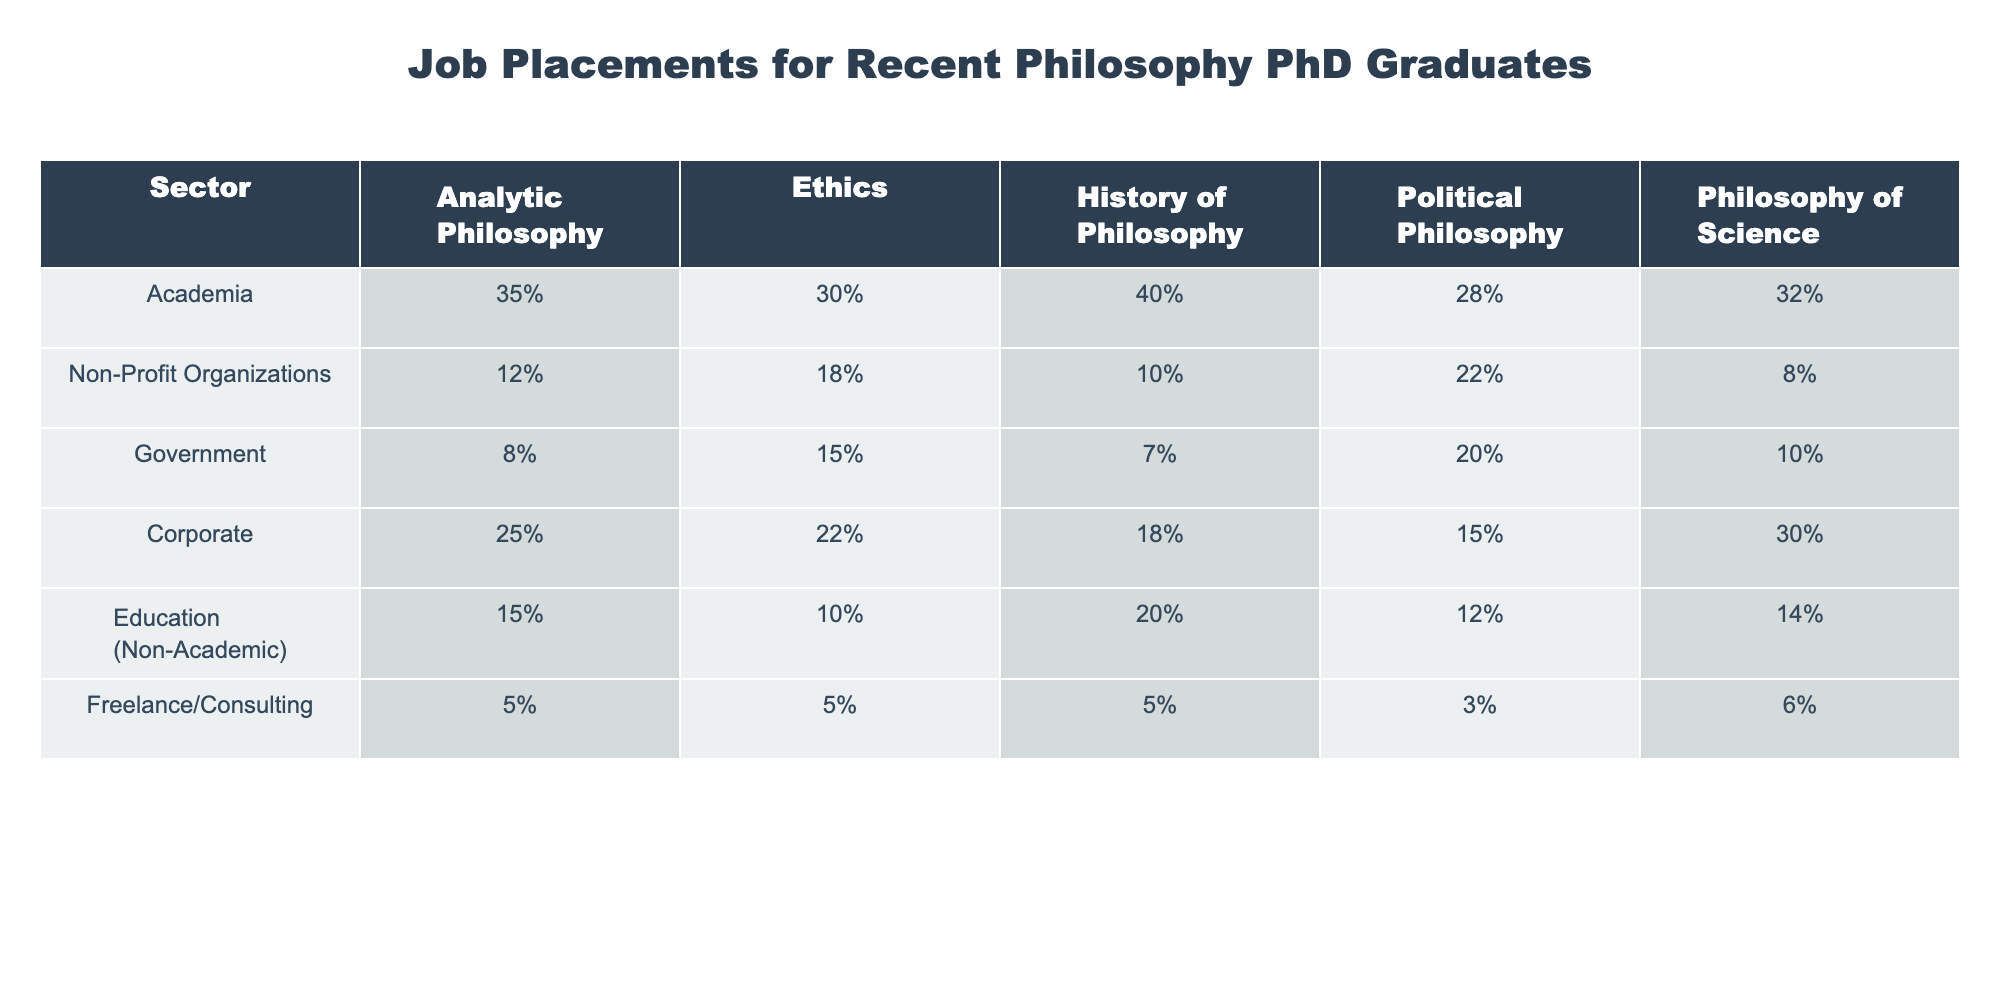What percentage of recent philosophy PhD graduates are placed in academia with a specialization in Ethics? The table shows the percentage of job placements by sector and specialization. For Academia under Ethics, the percentage is 30%.
Answer: 30% Which sector has the highest percentage of placements for graduates specializing in Political Philosophy? The table indicates that Government has the highest percentage (20%) for Political Philosophy placements.
Answer: Government How does the percentage of placements in Corporate compare to Non-Profit Organizations for graduates in Analytic Philosophy? The table shows Corporate placements at 25% and Non-Profit Organizations at 12%. To find the difference: 25% - 12% = 13%.
Answer: 13% What is the average placement percentage across all sectors for graduates specializing in the Philosophy of Science? Adding the percentages for Philosophy of Science across all sectors: (32% + 8% + 10% + 30% + 14% + 6%) = 100%, then dividing by the number of sectors (6): 100% / 6 = 16.67%.
Answer: 16.67% Is it true that more graduates specializing in History of Philosophy are placed in Government than in Education (Non-Academic)? The table indicates Government placements for History of Philosophy at 7% and Education (Non-Academic) at 20%. Since 7% is less than 20%, the statement is false.
Answer: No Which specialization has the lowest percentage of placements in Freelance/Consulting, and what is that percentage? The table shows that all specializations have the same percentage (5%) in Freelance/Consulting, indicating it is the lowest for each.
Answer: 5% If we compare the average percentages of placements for graduates in Analytic Philosophy and the Philosophy of Science, which one is higher, and by how much? The average for Analytic Philosophy = (35% + 12% + 8% + 25% + 15% + 5%) / 6 = 15%. The average for Philosophy of Science = (32% + 8% + 10% + 30% + 14% + 6%) / 6 = 16.67%. So, 16.67% - 15% = 1.67%. The average for Philosophy of Science is higher by 1.67%.
Answer: Philosophy of Science is higher by 1.67% What percentage of graduates in Education (Non-Academic) are placed in Corporate jobs? The table shows that 15% of graduates in the Education (Non-Academic) sector are placed in Corporate.
Answer: 15% Identify the sectors where the placement percentage is below 10% for the graduates specializing in Ethics. The table shows that both Government (15%) and Freelance/Consulting (5%) have placements below 10% for Ethics. By careful observation, only Freelance/Consulting meets this criteria.
Answer: Freelance/Consulting Among the sectors listed, which has the highest overall placement percentage and what is that percentage across all specializations? Reviewing each row, Corporate matches the highest placement percentage of 30% when looking at the specialization of Philosophy of Science. This is the highest overall from the table.
Answer: 30% 